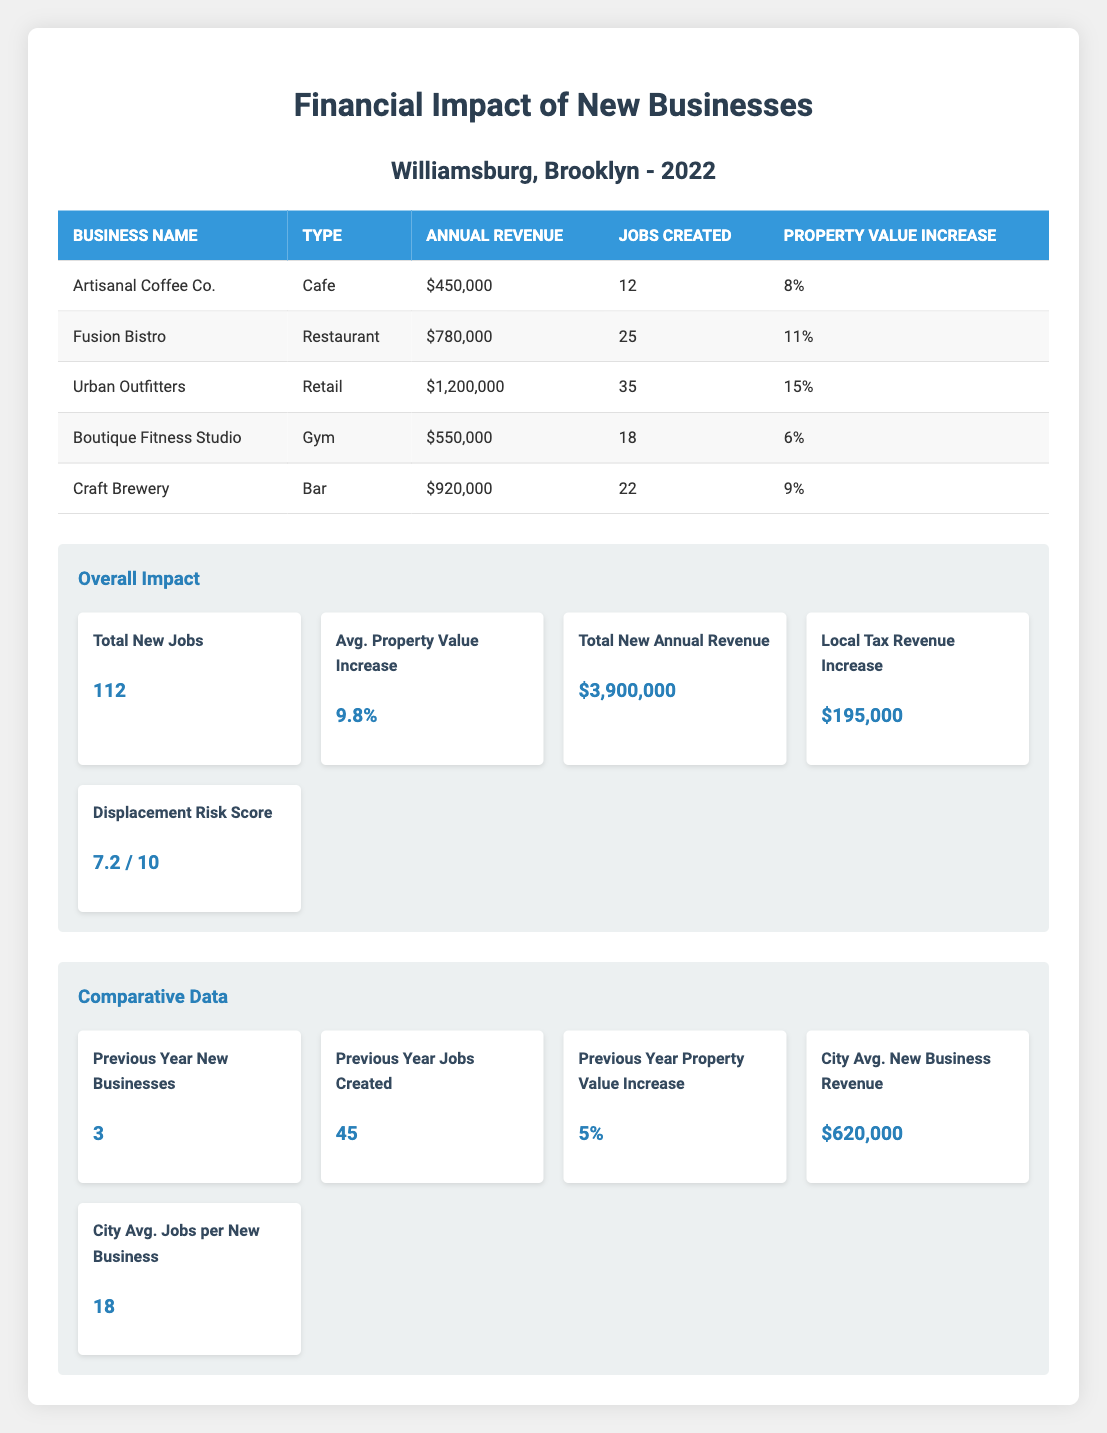What is the total annual revenue generated by new businesses in Williamsburg? The table lists the annual revenue for each new business. We can sum these values: 450000 + 780000 + 1200000 + 550000 + 920000 = 3900000.
Answer: 3900000 How many total new jobs were created by the new businesses? In the table, we can see the jobs created by each business, which are 12, 25, 35, 18, and 22. Summing these gives us: 12 + 25 + 35 + 18 + 22 = 112.
Answer: 112 What was the average property value increase among these businesses? The property value increases from each business are 0.08, 0.11, 0.15, 0.06, and 0.09. To find the average, we sum these and divide by the number of businesses: (0.08 + 0.11 + 0.15 + 0.06 + 0.09) / 5 = 0.098 or 9.8%.
Answer: 9.8% Did any of the businesses create more than 30 jobs? Looking at the jobs created, Urban Outfitters created 35 jobs, which is more than 30. The rest created fewer. Therefore, the answer is yes.
Answer: Yes What is the displacement risk score for Williamsburg? The table states that the displacement risk score is 7.2 out of 10. There is no further reasoning required as this value is directly listed.
Answer: 7.2 How does the total annual revenue of new businesses in 2022 compare to the city average new business revenue? We found the total annual revenue is 3900000, while the city average new business revenue is 620000. Since 3900000 is greater than 620000, Williamsburg's businesses performed better financially on average.
Answer: Greater What was the property value increase in the previous year? In the comparative data section, it states that the previous year's property value increase was 0.05.
Answer: 0.05 What percentage of the total jobs created were attributed to Urban Outfitters? Urban Outfitters created 35 jobs out of a total of 112 jobs. To find the percentage, we calculate (35 / 112) * 100 = 31.25%.
Answer: 31.25% How many new businesses opened in Williamsburg compared to the previous year? The current year had 5 new businesses, compared to 3 the previous year. We find the difference: 5 - 3 = 2 more businesses opened.
Answer: 2 more What is the average number of jobs created per new business in the current year? With a total of 112 new jobs from 5 businesses, the average is calculated as 112 / 5 = 22.4 jobs per business.
Answer: 22.4 